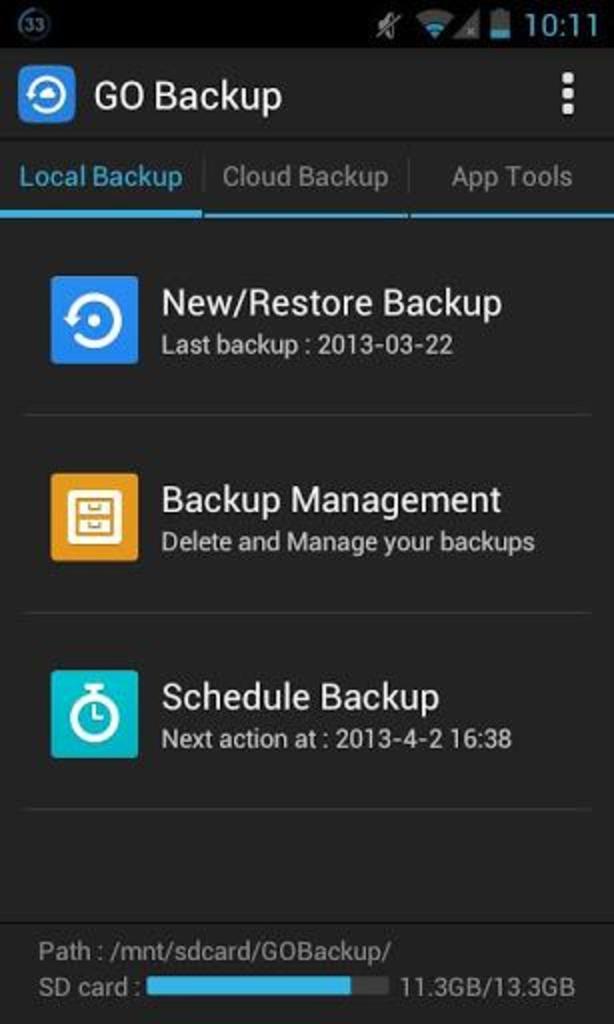What time is shown here?
Offer a terse response. 10:11. What is the name of the app running?
Offer a terse response. Go backup. 